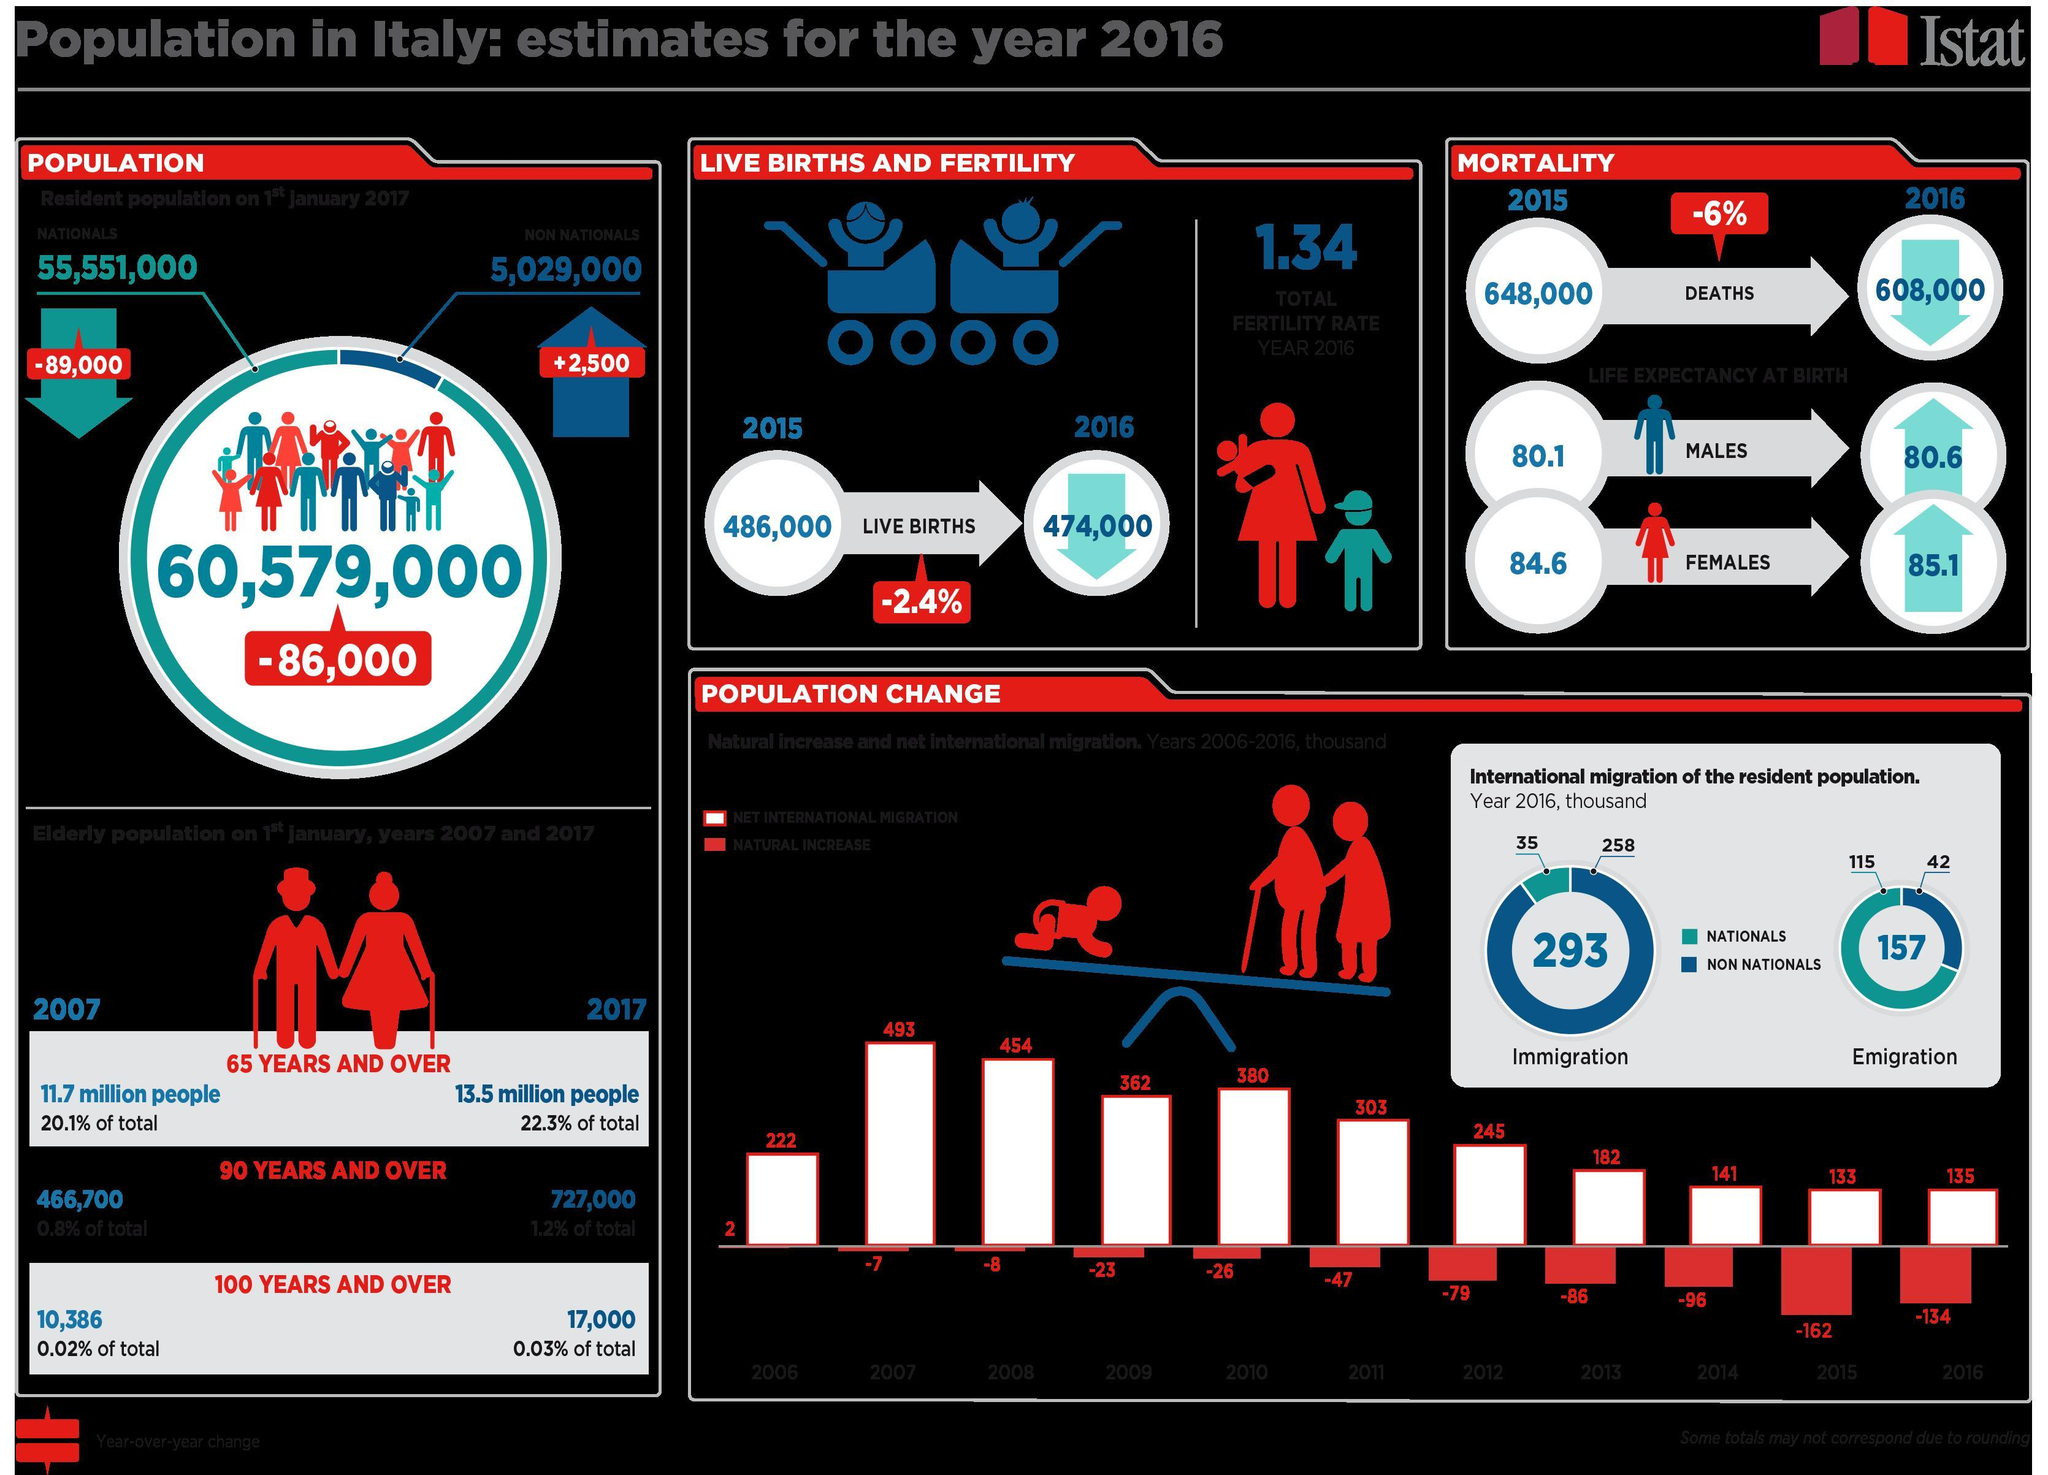What is the difference between the emigration of nationals and non-nationals?
Answer the question with a short phrase. 73 What is the difference between the immigration of non-nationals and nationals? 223 